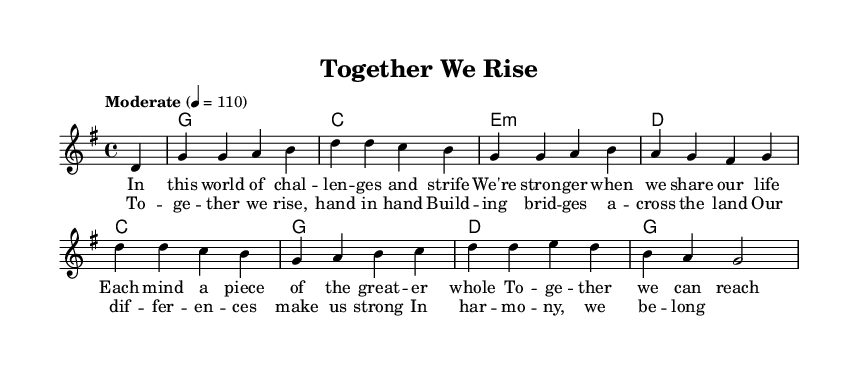What is the key signature of this music? The key signature indicated is G major, which has one sharp (F#). This can be identified by looking at the beginning of the music where the key signature is displayed.
Answer: G major What is the time signature of this piece? The time signature is 4/4, which is denoted at the beginning of the staff. This indicates four beats in each measure and a quarter note receives one beat.
Answer: 4/4 What is the tempo marking for this music? The tempo marking is "Moderate" at a quarter note equals 110 beats per minute. This notation tells the musician how fast to play the piece.
Answer: Moderate How many measures are in the verse section? The verse section consists of 4 measures, as counted by the number of vertical lines separating the sections of music.
Answer: 4 What is the main theme of the lyrics in the chorus? The main theme revolves around collaboration and unity, emphasizing that working together makes individuals and the whole group stronger. This can be observed by examining the lyrics.
Answer: Collaboration and unity What type of chords are primarily used in the harmonies? The harmonies primarily use major and minor chords, which are typical in country rock music, offering a rich harmonic structure that supports the melody. This conclusion can be drawn by analyzing the chord names present under the melody.
Answer: Major and minor chords What contributes to the "Country Rock" genre in this piece? The blend of traditional country themes with rock elements, such as the upbeat tempo and relatable lyrics about teamwork, aligns it with the "Country Rock" genre. This can be discerned by the stylistic choices in the melody and lyrics.
Answer: Upbeat tempo and relatable lyrics 